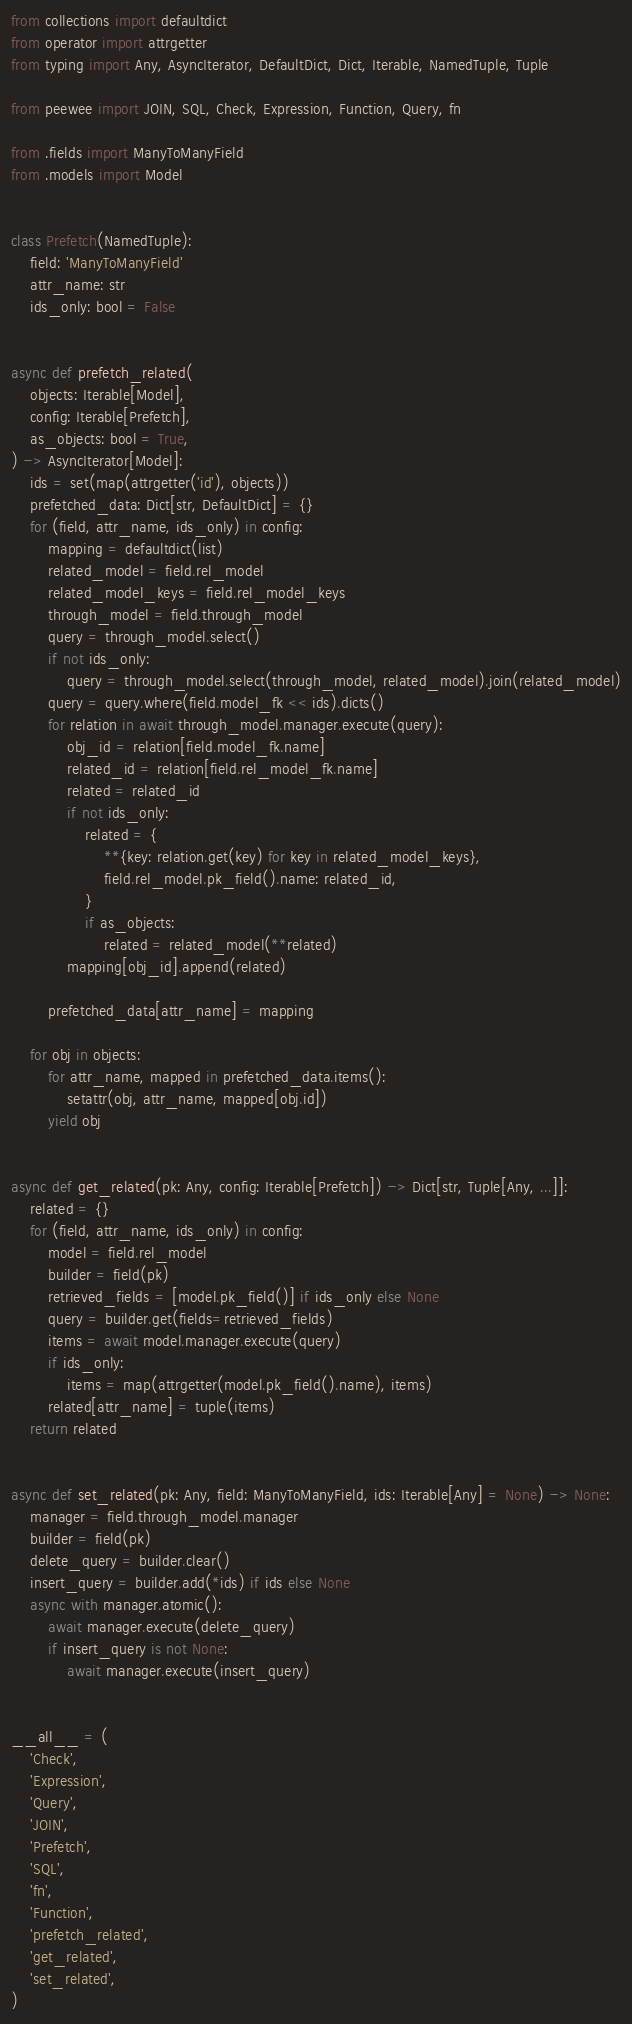Convert code to text. <code><loc_0><loc_0><loc_500><loc_500><_Python_>from collections import defaultdict
from operator import attrgetter
from typing import Any, AsyncIterator, DefaultDict, Dict, Iterable, NamedTuple, Tuple

from peewee import JOIN, SQL, Check, Expression, Function, Query, fn

from .fields import ManyToManyField
from .models import Model


class Prefetch(NamedTuple):
    field: 'ManyToManyField'
    attr_name: str
    ids_only: bool = False


async def prefetch_related(
    objects: Iterable[Model],
    config: Iterable[Prefetch],
    as_objects: bool = True,
) -> AsyncIterator[Model]:
    ids = set(map(attrgetter('id'), objects))
    prefetched_data: Dict[str, DefaultDict] = {}
    for (field, attr_name, ids_only) in config:
        mapping = defaultdict(list)
        related_model = field.rel_model
        related_model_keys = field.rel_model_keys
        through_model = field.through_model
        query = through_model.select()
        if not ids_only:
            query = through_model.select(through_model, related_model).join(related_model)
        query = query.where(field.model_fk << ids).dicts()
        for relation in await through_model.manager.execute(query):
            obj_id = relation[field.model_fk.name]
            related_id = relation[field.rel_model_fk.name]
            related = related_id
            if not ids_only:
                related = {
                    **{key: relation.get(key) for key in related_model_keys},
                    field.rel_model.pk_field().name: related_id,
                }
                if as_objects:
                    related = related_model(**related)
            mapping[obj_id].append(related)

        prefetched_data[attr_name] = mapping

    for obj in objects:
        for attr_name, mapped in prefetched_data.items():
            setattr(obj, attr_name, mapped[obj.id])
        yield obj


async def get_related(pk: Any, config: Iterable[Prefetch]) -> Dict[str, Tuple[Any, ...]]:
    related = {}
    for (field, attr_name, ids_only) in config:
        model = field.rel_model
        builder = field(pk)
        retrieved_fields = [model.pk_field()] if ids_only else None
        query = builder.get(fields=retrieved_fields)
        items = await model.manager.execute(query)
        if ids_only:
            items = map(attrgetter(model.pk_field().name), items)
        related[attr_name] = tuple(items)
    return related


async def set_related(pk: Any, field: ManyToManyField, ids: Iterable[Any] = None) -> None:
    manager = field.through_model.manager
    builder = field(pk)
    delete_query = builder.clear()
    insert_query = builder.add(*ids) if ids else None
    async with manager.atomic():
        await manager.execute(delete_query)
        if insert_query is not None:
            await manager.execute(insert_query)


__all__ = (
    'Check',
    'Expression',
    'Query',
    'JOIN',
    'Prefetch',
    'SQL',
    'fn',
    'Function',
    'prefetch_related',
    'get_related',
    'set_related',
)
</code> 